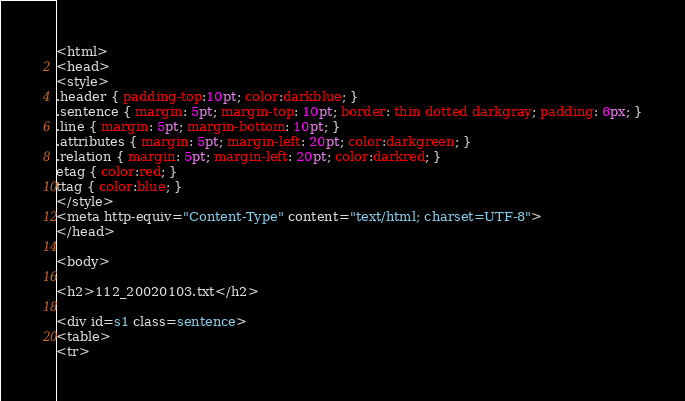<code> <loc_0><loc_0><loc_500><loc_500><_HTML_><html>
<head>
<style>
.header { padding-top:10pt; color:darkblue; }
.sentence { margin: 5pt; margin-top: 10pt; border: thin dotted darkgray; padding: 6px; }
.line { margin: 5pt; margin-bottom: 10pt; }
.attributes { margin: 5pt; margin-left: 20pt; color:darkgreen; }
.relation { margin: 5pt; margin-left: 20pt; color:darkred; }
etag { color:red; }
ttag { color:blue; }
</style>
<meta http-equiv="Content-Type" content="text/html; charset=UTF-8">
</head>

<body>

<h2>112_20020103.txt</h2>

<div id=s1 class=sentence>
<table>
<tr></code> 